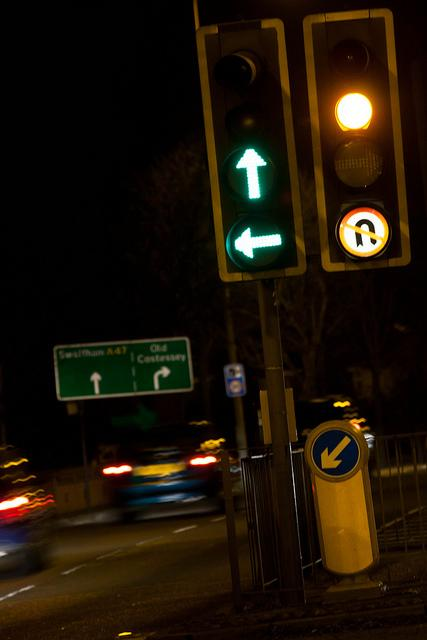What type of signs are these? traffic 